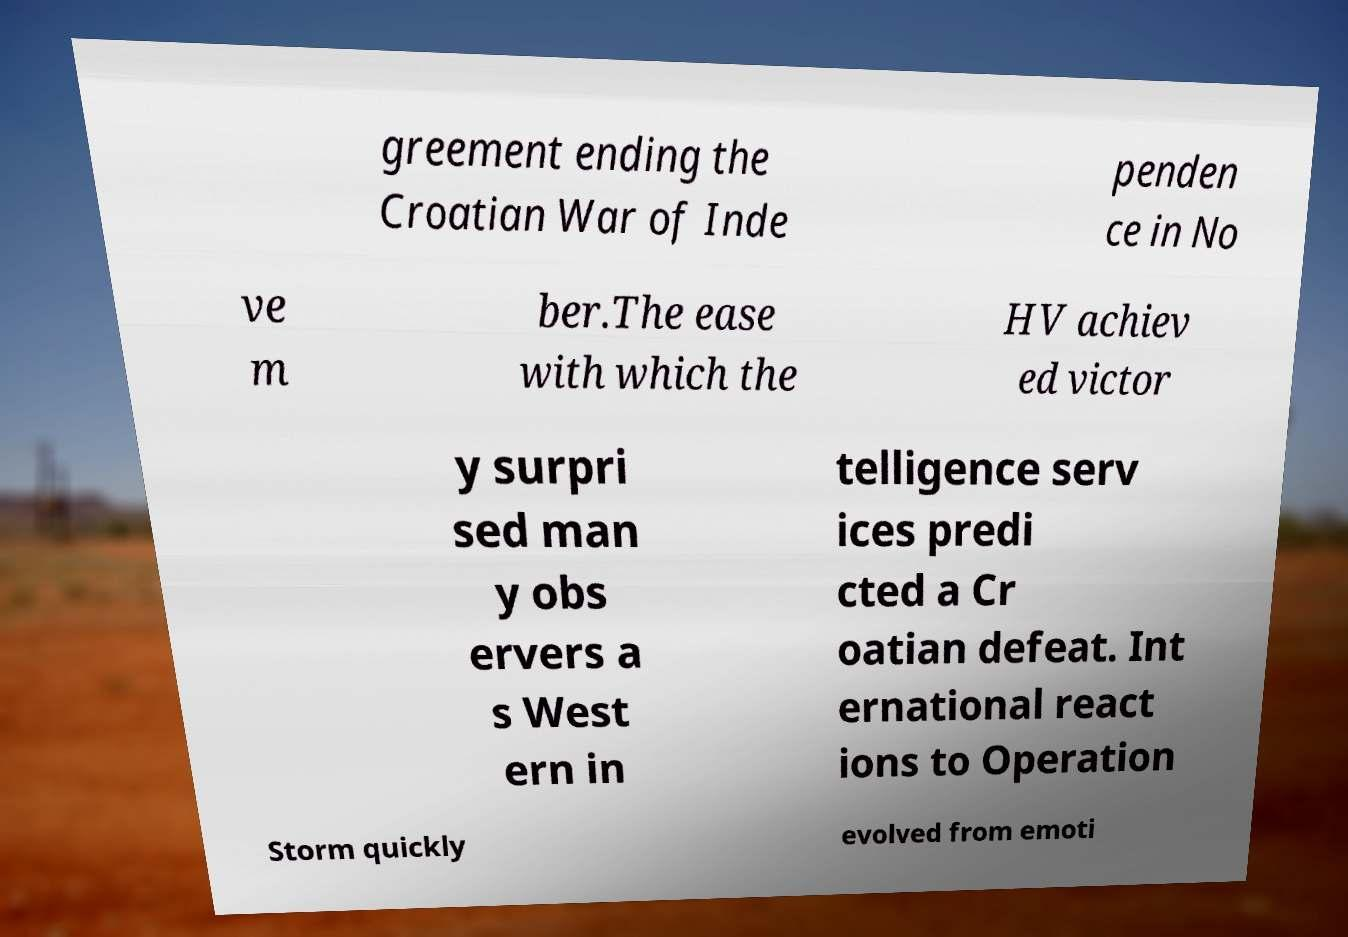Please read and relay the text visible in this image. What does it say? greement ending the Croatian War of Inde penden ce in No ve m ber.The ease with which the HV achiev ed victor y surpri sed man y obs ervers a s West ern in telligence serv ices predi cted a Cr oatian defeat. Int ernational react ions to Operation Storm quickly evolved from emoti 